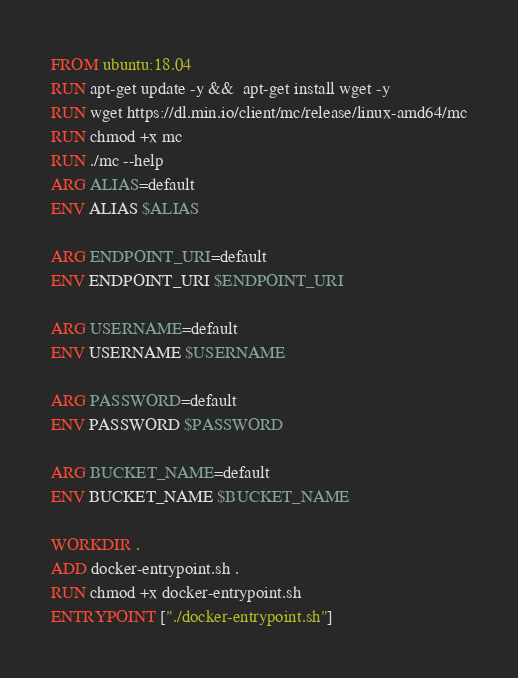Convert code to text. <code><loc_0><loc_0><loc_500><loc_500><_Dockerfile_>FROM ubuntu:18.04 
RUN apt-get update -y &&  apt-get install wget -y
RUN wget https://dl.min.io/client/mc/release/linux-amd64/mc
RUN chmod +x mc
RUN ./mc --help
ARG ALIAS=default
ENV ALIAS $ALIAS

ARG ENDPOINT_URI=default
ENV ENDPOINT_URI $ENDPOINT_URI

ARG USERNAME=default
ENV USERNAME $USERNAME

ARG PASSWORD=default
ENV PASSWORD $PASSWORD

ARG BUCKET_NAME=default
ENV BUCKET_NAME $BUCKET_NAME

WORKDIR .
ADD docker-entrypoint.sh .
RUN chmod +x docker-entrypoint.sh
ENTRYPOINT ["./docker-entrypoint.sh"]</code> 